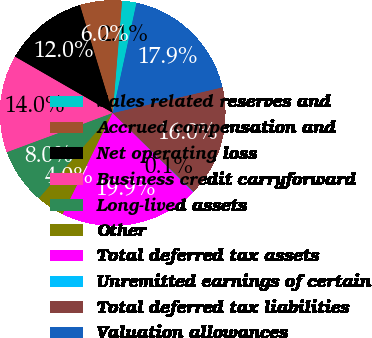Convert chart. <chart><loc_0><loc_0><loc_500><loc_500><pie_chart><fcel>Sales related reserves and<fcel>Accrued compensation and<fcel>Net operating loss<fcel>Business credit carryforward<fcel>Long-lived assets<fcel>Other<fcel>Total deferred tax assets<fcel>Unremitted earnings of certain<fcel>Total deferred tax liabilities<fcel>Valuation allowances<nl><fcel>2.06%<fcel>6.03%<fcel>11.99%<fcel>13.97%<fcel>8.01%<fcel>4.04%<fcel>19.93%<fcel>0.07%<fcel>15.96%<fcel>17.94%<nl></chart> 